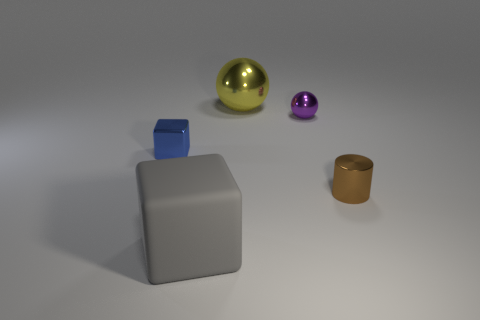There is a tiny object to the left of the large gray rubber object; does it have the same shape as the big rubber object?
Make the answer very short. Yes. The tiny blue object is what shape?
Your answer should be compact. Cube. There is a large thing behind the gray object that is on the right side of the block behind the matte cube; what is it made of?
Provide a short and direct response. Metal. What number of objects are small cyan shiny things or tiny brown objects?
Provide a short and direct response. 1. Do the big thing that is to the right of the gray matte object and the large gray object have the same material?
Your response must be concise. No. What number of things are large gray matte blocks to the left of the large sphere or big cyan rubber objects?
Provide a succinct answer. 1. There is a small cylinder that is the same material as the tiny purple thing; what color is it?
Your answer should be very brief. Brown. Are there any blue blocks of the same size as the purple object?
Provide a succinct answer. Yes. There is a big object that is behind the metallic cylinder; is it the same color as the metallic cylinder?
Provide a short and direct response. No. What color is the shiny object that is both to the left of the tiny sphere and right of the tiny block?
Your answer should be very brief. Yellow. 